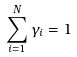<formula> <loc_0><loc_0><loc_500><loc_500>\sum _ { i = 1 } ^ { N } \gamma _ { i } = 1</formula> 